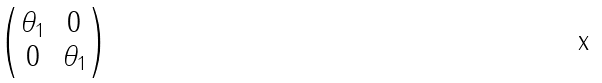Convert formula to latex. <formula><loc_0><loc_0><loc_500><loc_500>\begin{pmatrix} \theta _ { 1 } & 0 \\ 0 & \theta _ { 1 } \end{pmatrix}</formula> 